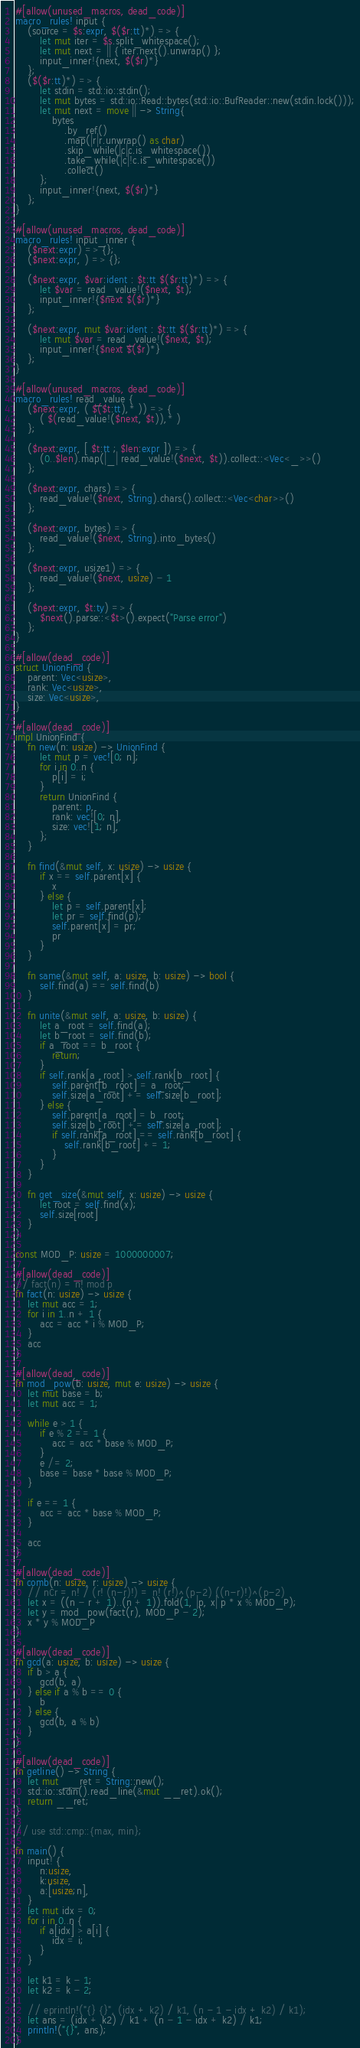<code> <loc_0><loc_0><loc_500><loc_500><_Rust_>#[allow(unused_macros, dead_code)]
macro_rules! input {
    (source = $s:expr, $($r:tt)*) => {
        let mut iter = $s.split_whitespace();
        let mut next = || { iter.next().unwrap() };
        input_inner!{next, $($r)*}
    };
    ($($r:tt)*) => {
        let stdin = std::io::stdin();
        let mut bytes = std::io::Read::bytes(std::io::BufReader::new(stdin.lock()));
        let mut next = move || -> String{
            bytes
                .by_ref()
                .map(|r|r.unwrap() as char)
                .skip_while(|c|c.is_whitespace())
                .take_while(|c|!c.is_whitespace())
                .collect()
        };
        input_inner!{next, $($r)*}
    };
}

#[allow(unused_macros, dead_code)]
macro_rules! input_inner {
    ($next:expr) => {};
    ($next:expr, ) => {};

    ($next:expr, $var:ident : $t:tt $($r:tt)*) => {
        let $var = read_value!($next, $t);
        input_inner!{$next $($r)*}
    };

    ($next:expr, mut $var:ident : $t:tt $($r:tt)*) => {
        let mut $var = read_value!($next, $t);
        input_inner!{$next $($r)*}
    };
}

#[allow(unused_macros, dead_code)]
macro_rules! read_value {
    ($next:expr, ( $($t:tt),* )) => {
        ( $(read_value!($next, $t)),* )
    };

    ($next:expr, [ $t:tt ; $len:expr ]) => {
        (0..$len).map(|_| read_value!($next, $t)).collect::<Vec<_>>()
    };

    ($next:expr, chars) => {
        read_value!($next, String).chars().collect::<Vec<char>>()
    };

    ($next:expr, bytes) => {
        read_value!($next, String).into_bytes()
    };

    ($next:expr, usize1) => {
        read_value!($next, usize) - 1
    };

    ($next:expr, $t:ty) => {
        $next().parse::<$t>().expect("Parse error")
    };
}

#[allow(dead_code)]
struct UnionFind {
    parent: Vec<usize>,
    rank: Vec<usize>,
    size: Vec<usize>,
}

#[allow(dead_code)]
impl UnionFind {
    fn new(n: usize) -> UnionFind {
        let mut p = vec![0; n];
        for i in 0..n {
            p[i] = i;
        }
        return UnionFind {
            parent: p,
            rank: vec![0; n],
            size: vec![1; n],
        };
    }

    fn find(&mut self, x: usize) -> usize {
        if x == self.parent[x] {
            x
        } else {
            let p = self.parent[x];
            let pr = self.find(p);
            self.parent[x] = pr;
            pr
        }
    }

    fn same(&mut self, a: usize, b: usize) -> bool {
        self.find(a) == self.find(b)
    }

    fn unite(&mut self, a: usize, b: usize) {
        let a_root = self.find(a);
        let b_root = self.find(b);
        if a_root == b_root {
            return;
        }
        if self.rank[a_root] > self.rank[b_root] {
            self.parent[b_root] = a_root;
            self.size[a_root] += self.size[b_root];
        } else {
            self.parent[a_root] = b_root;
            self.size[b_root] += self.size[a_root];
            if self.rank[a_root] == self.rank[b_root] {
                self.rank[b_root] += 1;
            }
        }
    }

    fn get_size(&mut self, x: usize) -> usize {
        let root = self.find(x);
        self.size[root]
    }
}

const MOD_P: usize = 1000000007;

#[allow(dead_code)]
// fact(n) = n! mod p
fn fact(n: usize) -> usize {
    let mut acc = 1;
    for i in 1..n + 1 {
        acc = acc * i % MOD_P;
    }
    acc
}

#[allow(dead_code)]
fn mod_pow(b: usize, mut e: usize) -> usize {
    let mut base = b;
    let mut acc = 1;

    while e > 1 {
        if e % 2 == 1 {
            acc = acc * base % MOD_P;
        }
        e /= 2;
        base = base * base % MOD_P;
    }

    if e == 1 {
        acc = acc * base % MOD_P;
    }

    acc
}

#[allow(dead_code)]
fn comb(n: usize, r: usize) -> usize {
    // nCr = n! / (r! (n-r)!) = n! (r!)^(p-2) ((n-r)!)^(p-2)
    let x = ((n - r + 1)..(n + 1)).fold(1, |p, x| p * x % MOD_P);
    let y = mod_pow(fact(r), MOD_P - 2);
    x * y % MOD_P
}

#[allow(dead_code)]
fn gcd(a: usize, b: usize) -> usize {
    if b > a {
        gcd(b, a)
    } else if a % b == 0 {
        b
    } else {
        gcd(b, a % b)
    }
}

#[allow(dead_code)]
fn getline() -> String {
    let mut __ret = String::new();
    std::io::stdin().read_line(&mut __ret).ok();
    return __ret;
}

// use std::cmp::{max, min};

fn main() {
    input! {
        n:usize,
        k:usize,
        a:[usize;n],
    }
    let mut idx = 0;
    for i in 0..n {
        if a[idx] > a[i] {
            idx = i;
        }
    }

    let k1 = k - 1;
    let k2 = k - 2;

    // eprintln!("{} {}", (idx + k2) / k1, (n - 1 - idx + k2) / k1);
    let ans = (idx + k2) / k1 + (n - 1 - idx + k2) / k1;
    println!("{}", ans);
}
</code> 